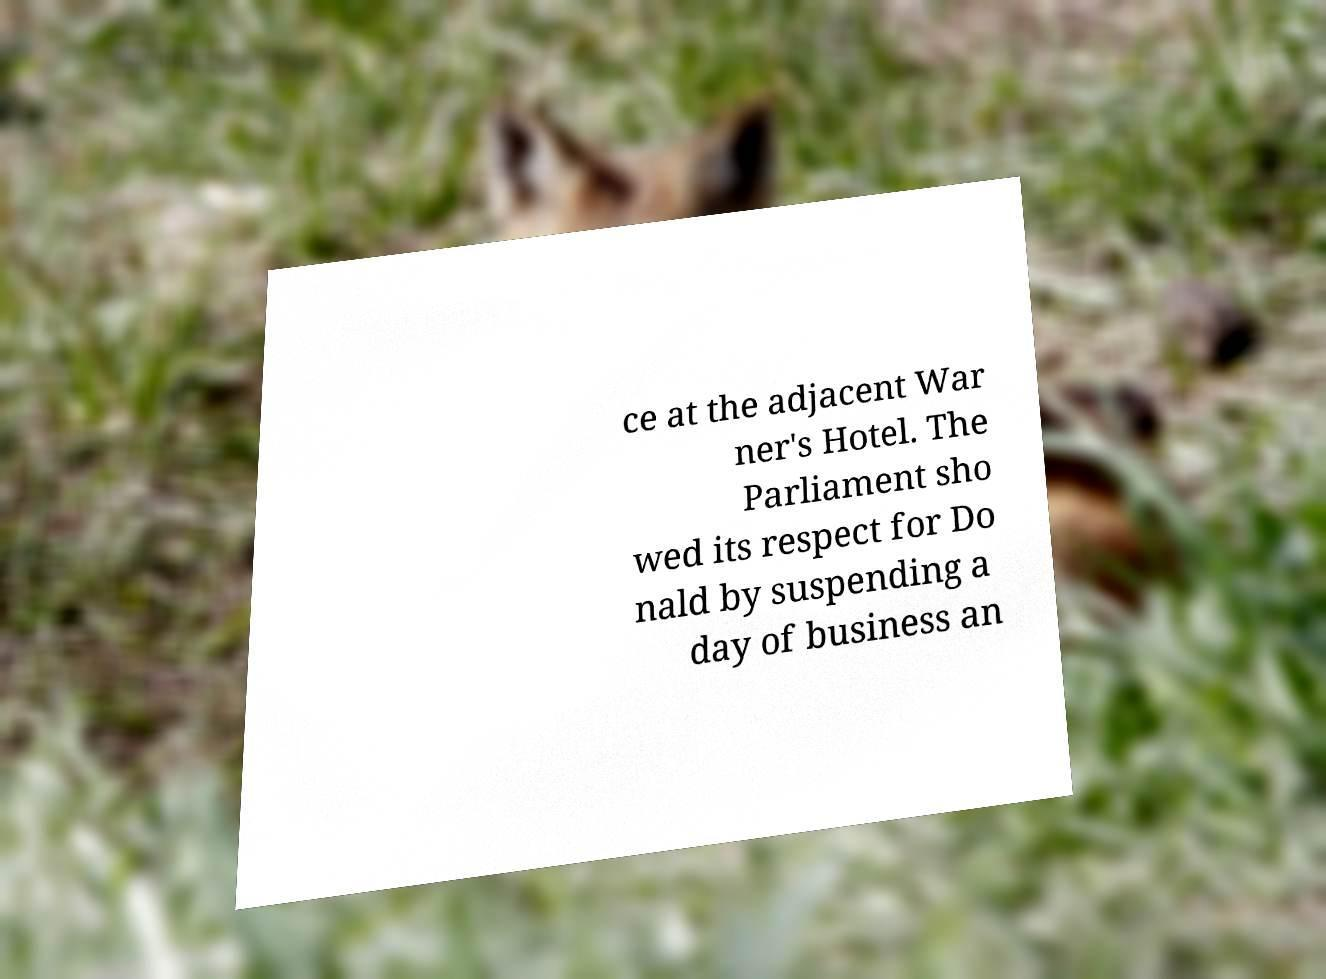Please identify and transcribe the text found in this image. ce at the adjacent War ner's Hotel. The Parliament sho wed its respect for Do nald by suspending a day of business an 